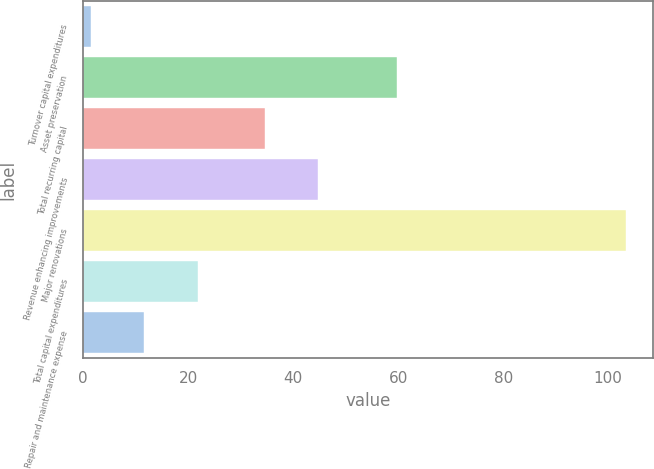<chart> <loc_0><loc_0><loc_500><loc_500><bar_chart><fcel>Turnover capital expenditures<fcel>Asset preservation<fcel>Total recurring capital<fcel>Revenue enhancing improvements<fcel>Major renovations<fcel>Total capital expenditures<fcel>Repair and maintenance expense<nl><fcel>1.5<fcel>59.7<fcel>34.6<fcel>44.78<fcel>103.3<fcel>21.86<fcel>11.68<nl></chart> 